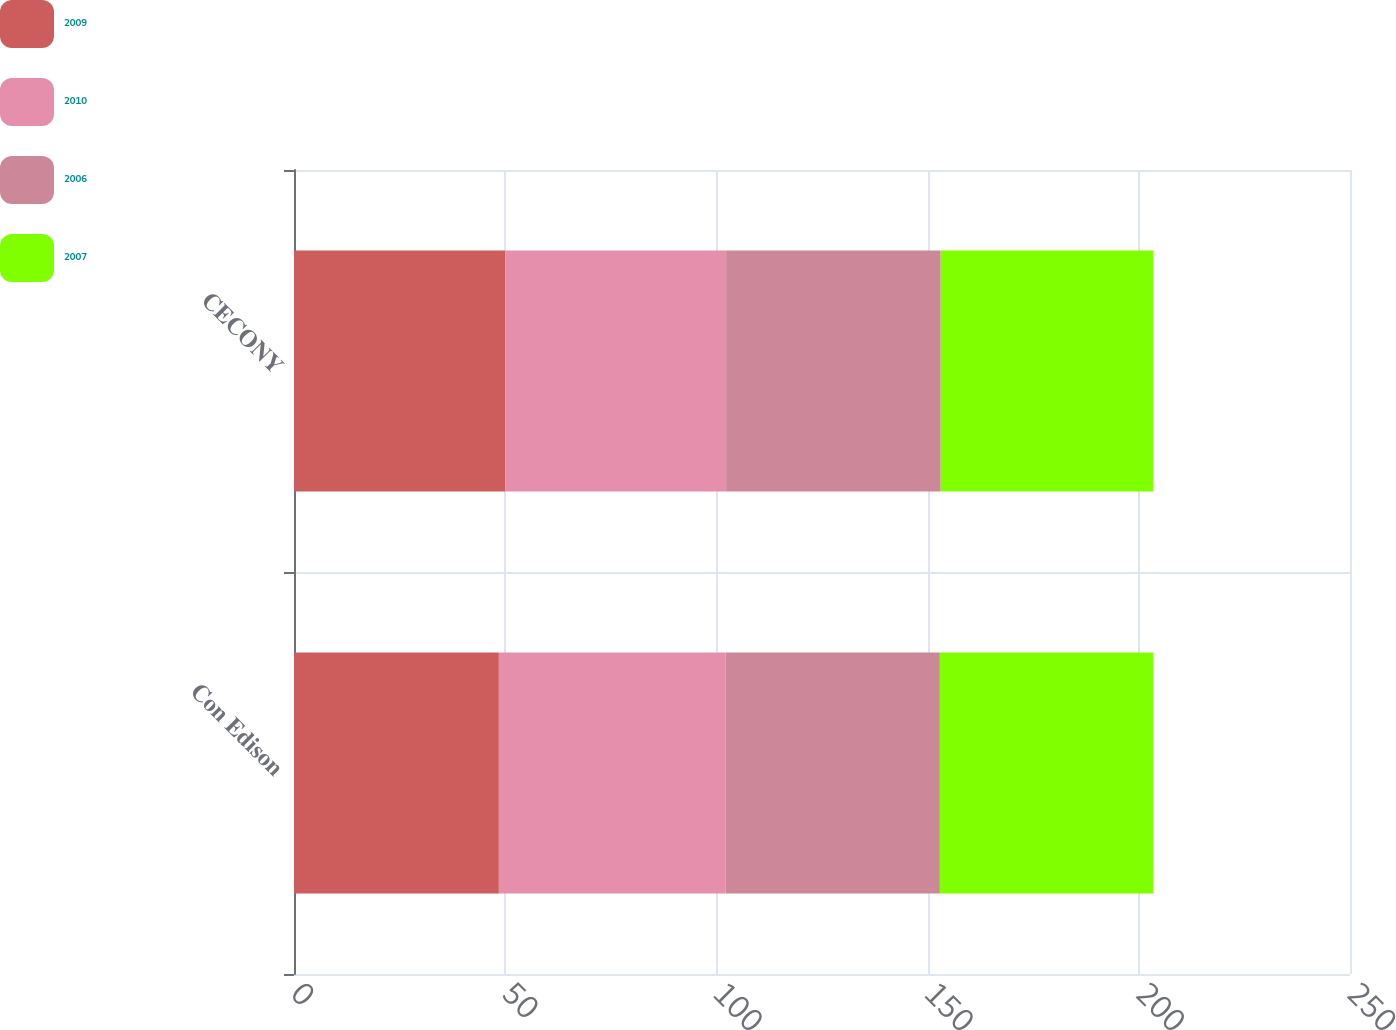Convert chart. <chart><loc_0><loc_0><loc_500><loc_500><stacked_bar_chart><ecel><fcel>Con Edison<fcel>CECONY<nl><fcel>2009<fcel>48.5<fcel>50<nl><fcel>2010<fcel>53.7<fcel>52.3<nl><fcel>2006<fcel>50.7<fcel>50.8<nl><fcel>2007<fcel>50.5<fcel>50.3<nl></chart> 